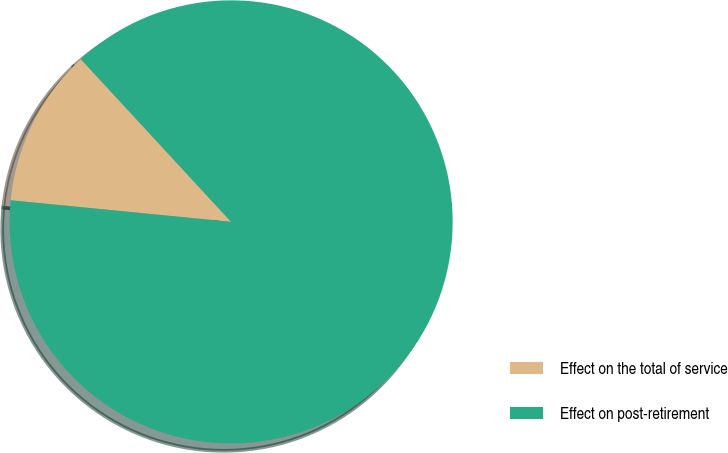Convert chart. <chart><loc_0><loc_0><loc_500><loc_500><pie_chart><fcel>Effect on the total of service<fcel>Effect on post-retirement<nl><fcel>11.58%<fcel>88.42%<nl></chart> 